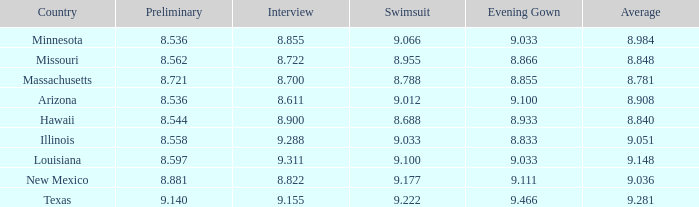Would you be able to parse every entry in this table? {'header': ['Country', 'Preliminary', 'Interview', 'Swimsuit', 'Evening Gown', 'Average'], 'rows': [['Minnesota', '8.536', '8.855', '9.066', '9.033', '8.984'], ['Missouri', '8.562', '8.722', '8.955', '8.866', '8.848'], ['Massachusetts', '8.721', '8.700', '8.788', '8.855', '8.781'], ['Arizona', '8.536', '8.611', '9.012', '9.100', '8.908'], ['Hawaii', '8.544', '8.900', '8.688', '8.933', '8.840'], ['Illinois', '8.558', '9.288', '9.033', '8.833', '9.051'], ['Louisiana', '8.597', '9.311', '9.100', '9.033', '9.148'], ['New Mexico', '8.881', '8.822', '9.177', '9.111', '9.036'], ['Texas', '9.140', '9.155', '9.222', '9.466', '9.281']]} What country had a swimsuit score of 8.788? Massachusetts. 